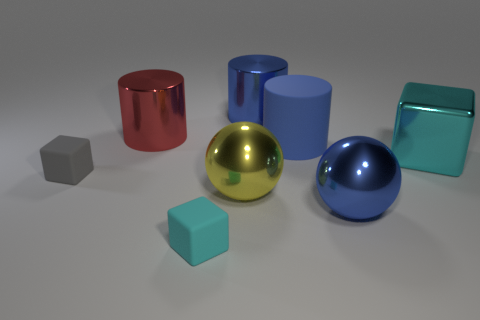How many other objects are the same shape as the yellow metal thing?
Your response must be concise. 1. There is a big blue object that is the same material as the gray cube; what shape is it?
Ensure brevity in your answer.  Cylinder. There is a rubber object in front of the small rubber object that is behind the big yellow sphere; what color is it?
Make the answer very short. Cyan. Do the cyan rubber thing and the big cyan object have the same shape?
Ensure brevity in your answer.  Yes. There is another big thing that is the same shape as the yellow metallic object; what is its material?
Provide a short and direct response. Metal. There is a cube right of the blue sphere in front of the blue shiny cylinder; is there a blue ball on the left side of it?
Keep it short and to the point. Yes. There is a large rubber thing; is it the same shape as the cyan object behind the big blue metallic sphere?
Your answer should be compact. No. There is a cylinder that is in front of the large red metallic cylinder; is it the same color as the metal cylinder to the right of the big red metal cylinder?
Your response must be concise. Yes. Are any large yellow spheres visible?
Give a very brief answer. Yes. Is there a tiny yellow cube that has the same material as the large blue sphere?
Your answer should be compact. No. 